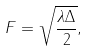<formula> <loc_0><loc_0><loc_500><loc_500>F = \sqrt { \frac { \lambda \Delta } { 2 } } ,</formula> 